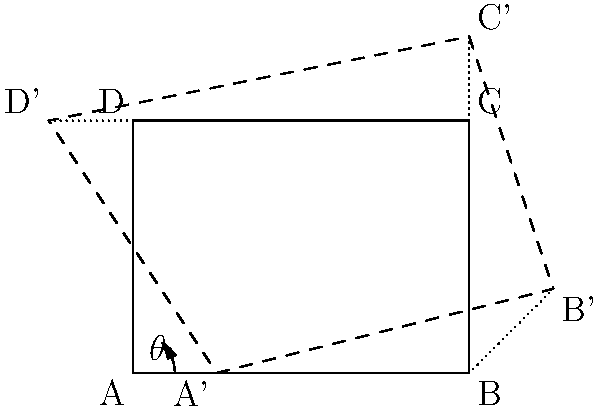In Photoshop, you want to rotate an image to change its perspective. The original image is represented by the solid rectangle ABCD, and the rotated image is shown by the dashed rectangle A'B'C'D'. If you want to achieve this transformation, what is the approximate angle $\theta$ (in degrees) you should rotate the image? To find the angle of rotation, let's follow these steps:

1. Observe that point A is the center of rotation, as it remains fixed (A and A' are the same point).

2. We can determine the angle by looking at how much point B has moved to B'.

3. The movement from B to B' forms a right-angled triangle with the original bottom edge of the image.

4. In this triangle:
   - The base (horizontal distance) is approximately 1 unit
   - The height (vertical distance) is approximately 1 unit

5. When the base and height of a right-angled triangle are equal, it forms a 45-degree angle.

6. However, the angle appears to be slightly less than 45 degrees in the image.

7. A good estimate for this angle would be around 30 to 35 degrees.

Given the approximate nature of visual estimation in Photoshop, an angle of about 30 degrees would likely achieve the desired perspective change.
Answer: Approximately 30° 